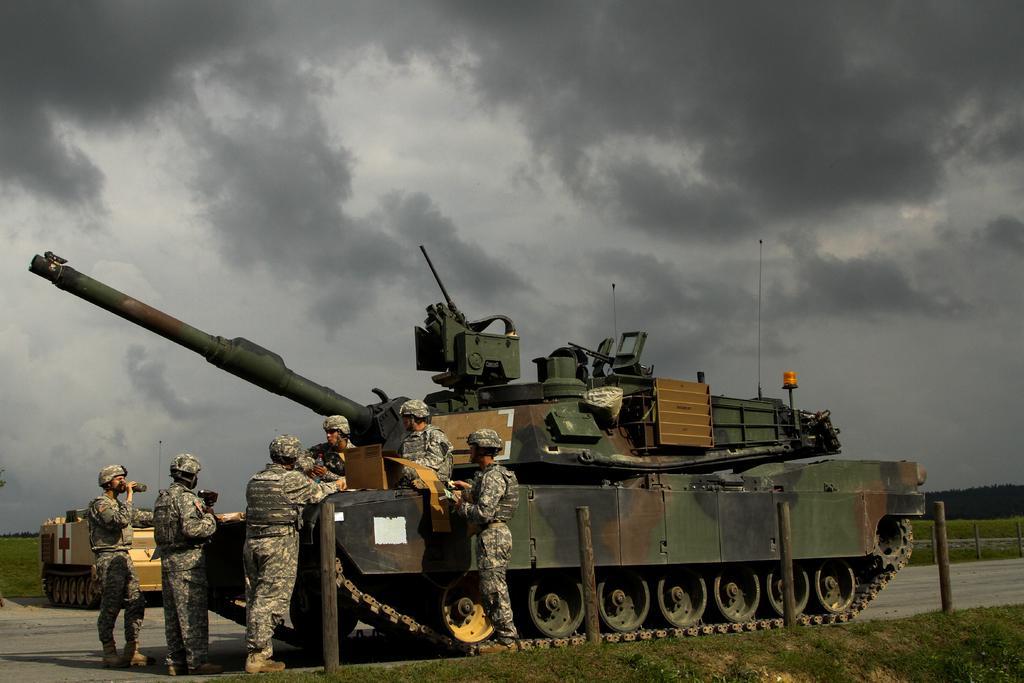Please provide a concise description of this image. In the picture we can see some group of persons wearing camouflage dress standing near the military tanker and in the background there is grass, there is road and there are some trees and top of the picture there is cloudy sky. 